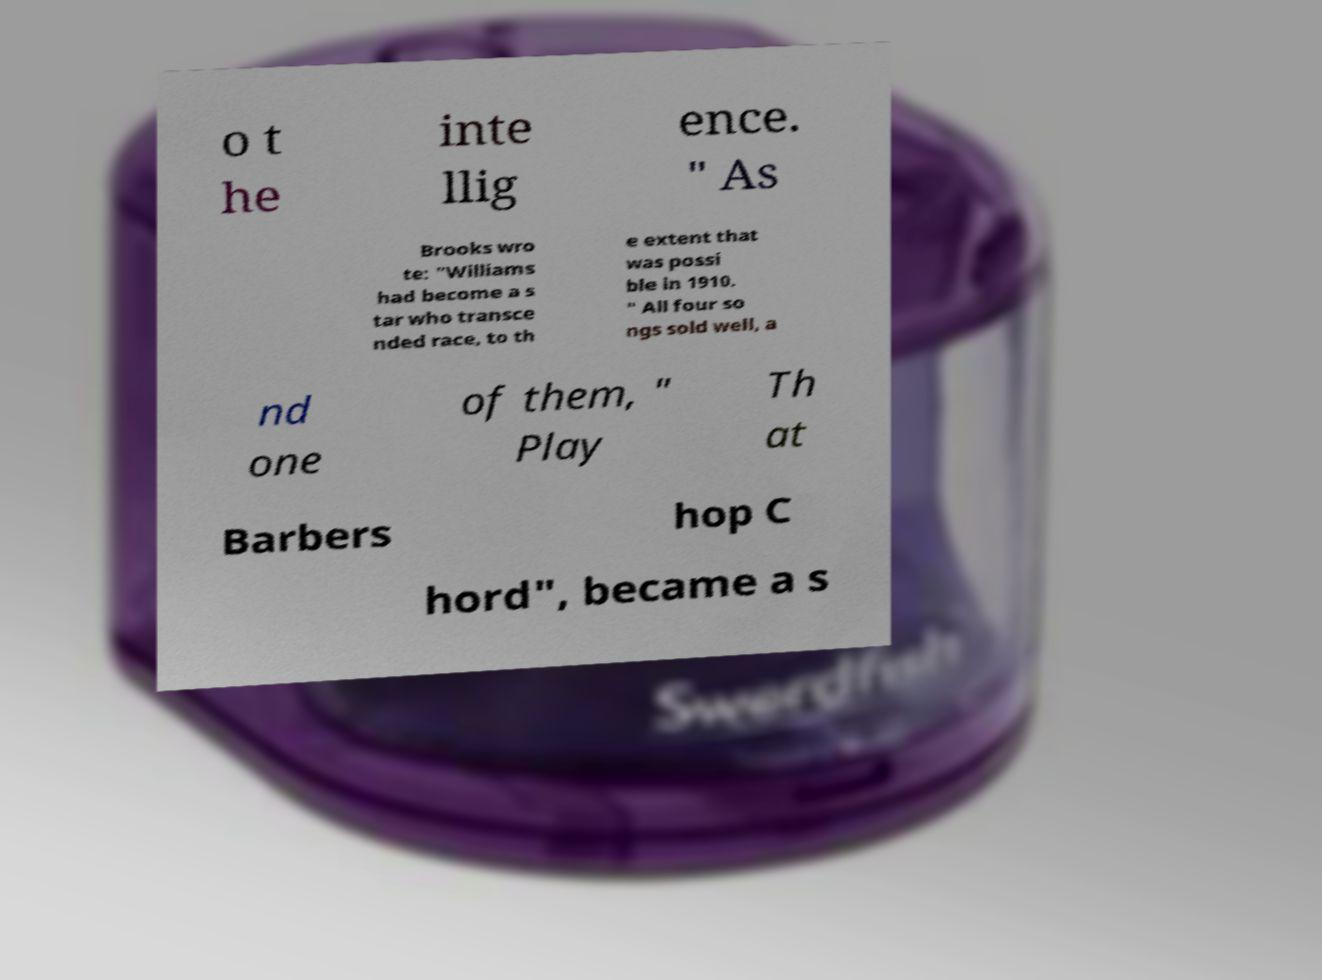Please identify and transcribe the text found in this image. o t he inte llig ence. " As Brooks wro te: "Williams had become a s tar who transce nded race, to th e extent that was possi ble in 1910. " All four so ngs sold well, a nd one of them, " Play Th at Barbers hop C hord", became a s 